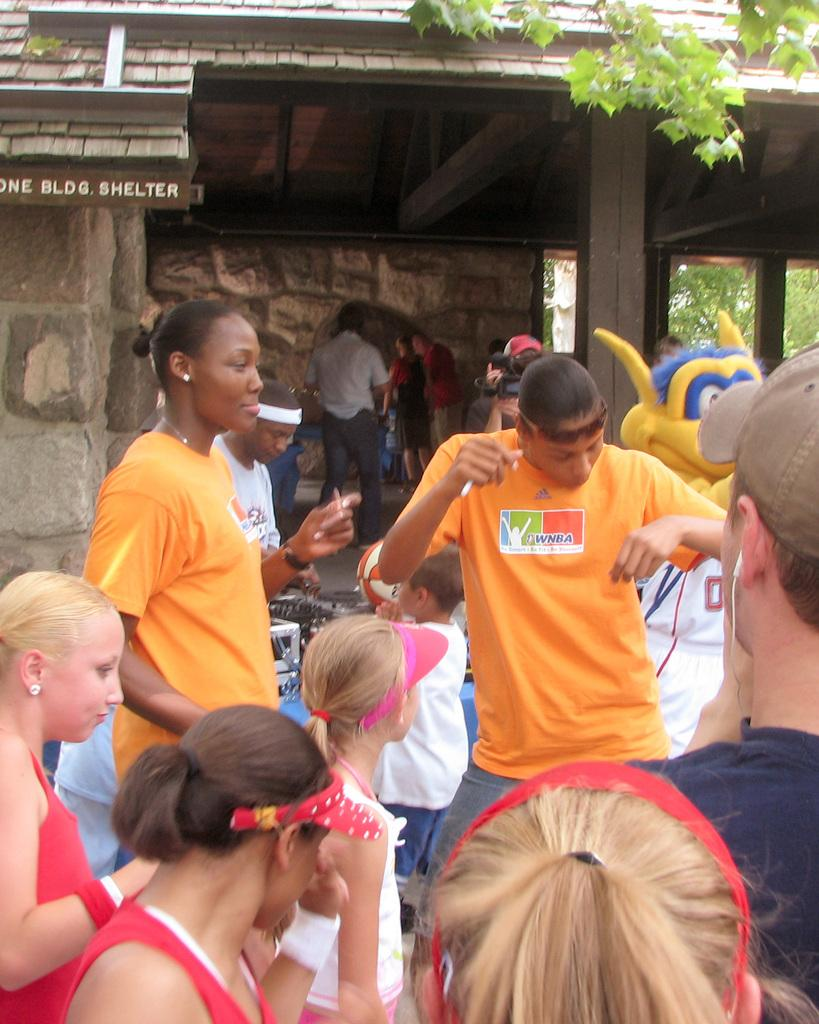How many people are in the image? There is a group of people in the image, but the exact number cannot be determined from the provided facts. What can be seen in the background of the image? In the background of the image, there is a board, a wall, poles, and trees. What might the board be used for? The purpose of the board cannot be determined from the provided facts. What type of star can be seen shining in the image? There is no star visible in the image; it features a group of people and various background elements. What type of produce is being grown in the image? There is no produce being grown in the image; it features a group of people and various background elements. 